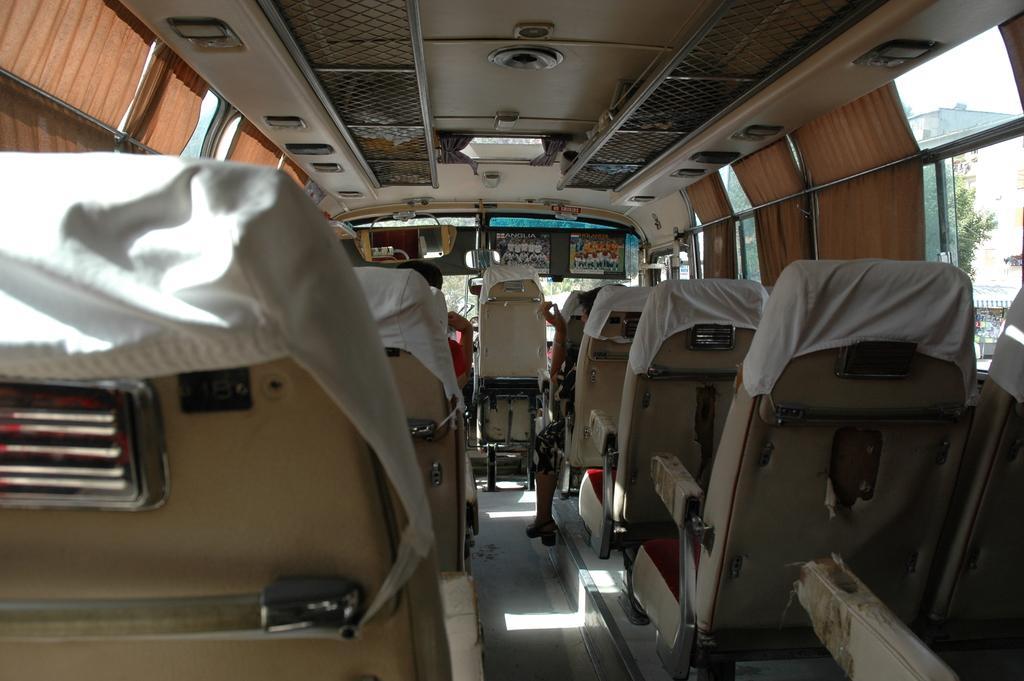Can you describe this image briefly? In this picture we can see an inside view of a vehicle, on the right side and left side there are seats and curtains, there are some lights at the top of the picture, on the right side there is a glass, from the glass we can see a tree and a building. 